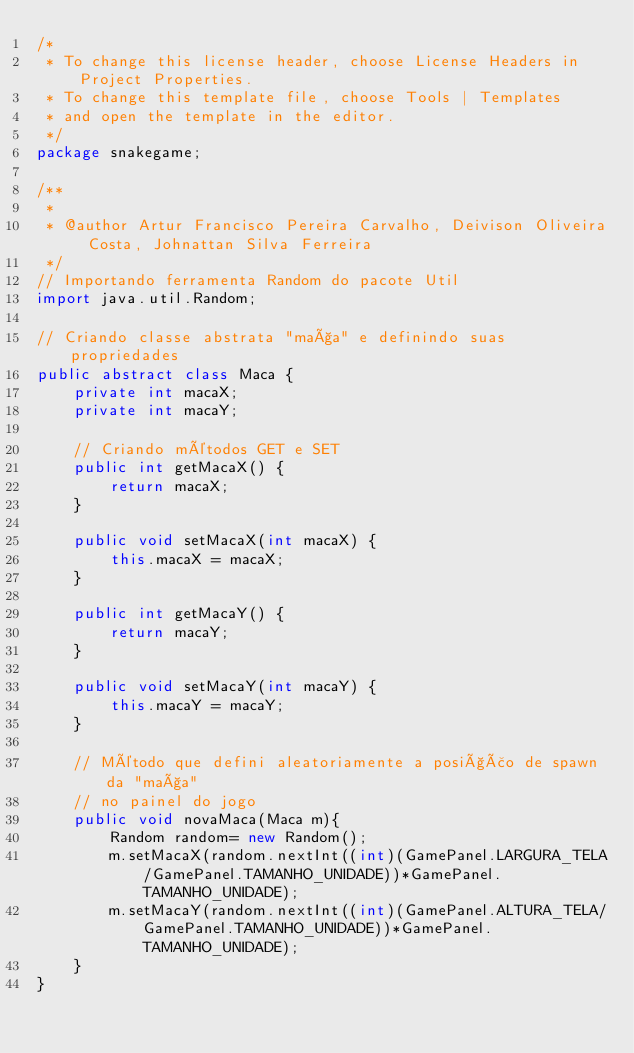Convert code to text. <code><loc_0><loc_0><loc_500><loc_500><_Java_>/*
 * To change this license header, choose License Headers in Project Properties.
 * To change this template file, choose Tools | Templates
 * and open the template in the editor.
 */
package snakegame;

/**
 *
 * @author Artur Francisco Pereira Carvalho, Deivison Oliveira Costa, Johnattan Silva Ferreira
 */
// Importando ferramenta Random do pacote Util 
import java.util.Random;

// Criando classe abstrata "maça" e definindo suas propriedades
public abstract class Maca {
    private int macaX;
    private int macaY;

    // Criando métodos GET e SET
    public int getMacaX() {
        return macaX;
    }

    public void setMacaX(int macaX) {
        this.macaX = macaX;
    }

    public int getMacaY() {
        return macaY;
    }

    public void setMacaY(int macaY) {
        this.macaY = macaY;
    }
    
    // Método que defini aleatoriamente a posição de spawn da "maça"
    // no painel do jogo
    public void novaMaca(Maca m){
        Random random= new Random();
        m.setMacaX(random.nextInt((int)(GamePanel.LARGURA_TELA/GamePanel.TAMANHO_UNIDADE))*GamePanel.TAMANHO_UNIDADE); 
        m.setMacaY(random.nextInt((int)(GamePanel.ALTURA_TELA/GamePanel.TAMANHO_UNIDADE))*GamePanel.TAMANHO_UNIDADE);
    }
}</code> 